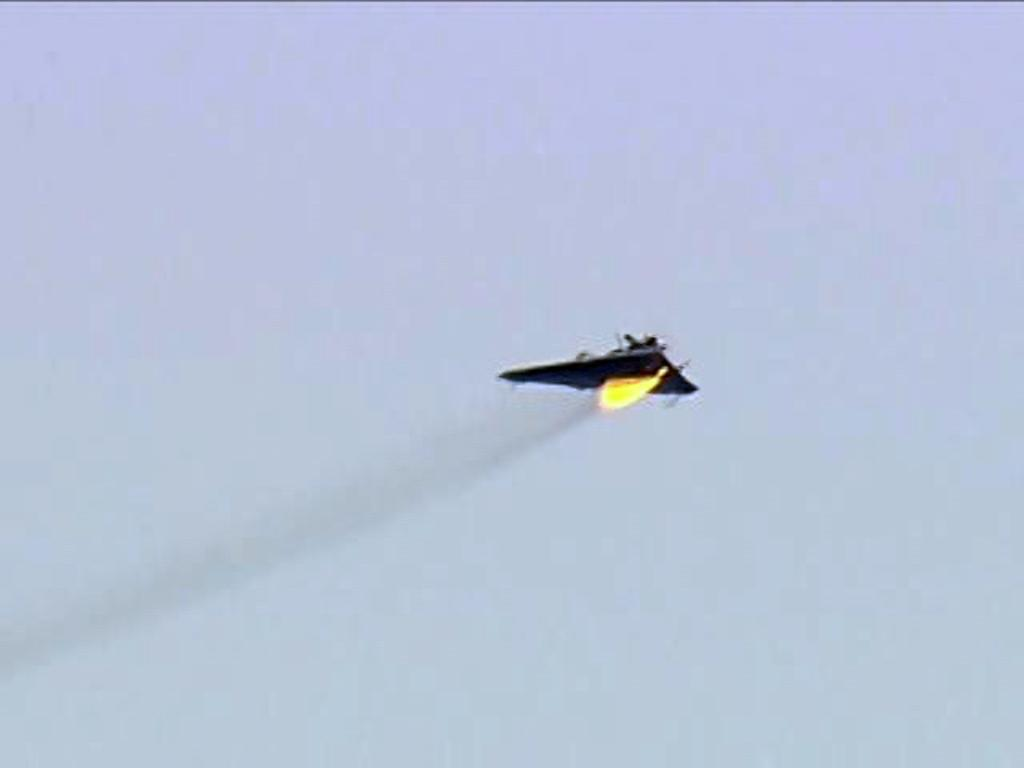What is the main subject of the image? There is an aircraft in the center of the image. What can be seen in the background of the image? The sky is visible in the background of the image. What type of zinc is used to build the aircraft in the image? There is no information about the materials used to build the aircraft in the image, and therefore no such detail can be determined. 